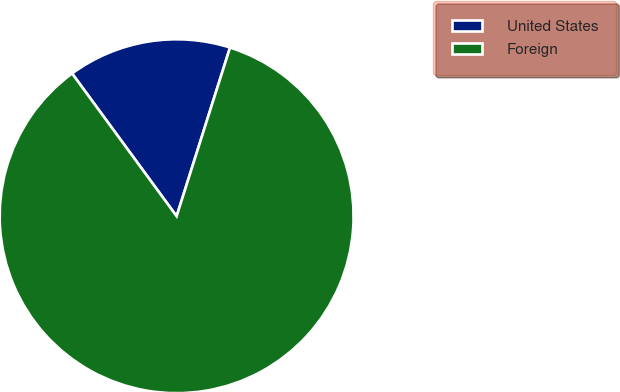Convert chart to OTSL. <chart><loc_0><loc_0><loc_500><loc_500><pie_chart><fcel>United States<fcel>Foreign<nl><fcel>14.94%<fcel>85.06%<nl></chart> 